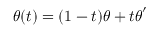<formula> <loc_0><loc_0><loc_500><loc_500>\boldsymbol \theta ( t ) = ( 1 - t ) \boldsymbol \theta + t \boldsymbol \theta ^ { \prime }</formula> 